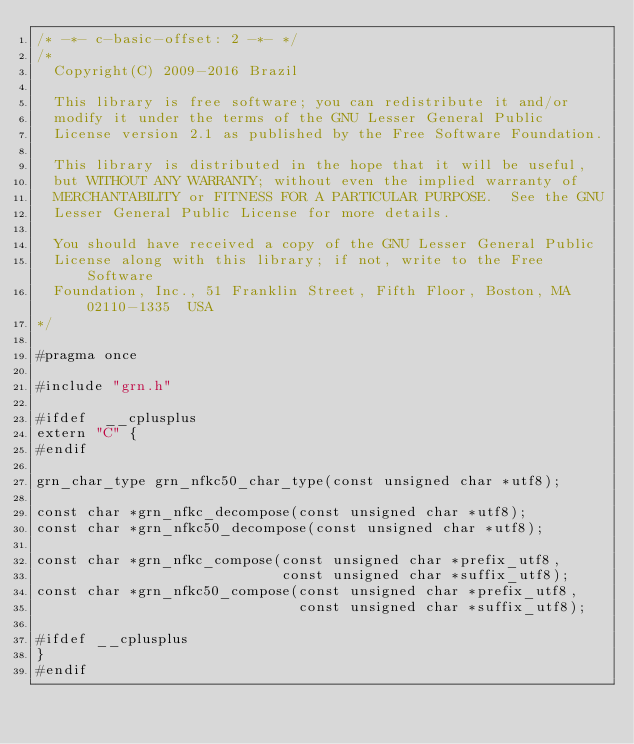Convert code to text. <code><loc_0><loc_0><loc_500><loc_500><_C_>/* -*- c-basic-offset: 2 -*- */
/*
  Copyright(C) 2009-2016 Brazil

  This library is free software; you can redistribute it and/or
  modify it under the terms of the GNU Lesser General Public
  License version 2.1 as published by the Free Software Foundation.

  This library is distributed in the hope that it will be useful,
  but WITHOUT ANY WARRANTY; without even the implied warranty of
  MERCHANTABILITY or FITNESS FOR A PARTICULAR PURPOSE.  See the GNU
  Lesser General Public License for more details.

  You should have received a copy of the GNU Lesser General Public
  License along with this library; if not, write to the Free Software
  Foundation, Inc., 51 Franklin Street, Fifth Floor, Boston, MA  02110-1335  USA
*/

#pragma once

#include "grn.h"

#ifdef	__cplusplus
extern "C" {
#endif

grn_char_type grn_nfkc50_char_type(const unsigned char *utf8);

const char *grn_nfkc_decompose(const unsigned char *utf8);
const char *grn_nfkc50_decompose(const unsigned char *utf8);

const char *grn_nfkc_compose(const unsigned char *prefix_utf8,
                             const unsigned char *suffix_utf8);
const char *grn_nfkc50_compose(const unsigned char *prefix_utf8,
                               const unsigned char *suffix_utf8);

#ifdef __cplusplus
}
#endif
</code> 